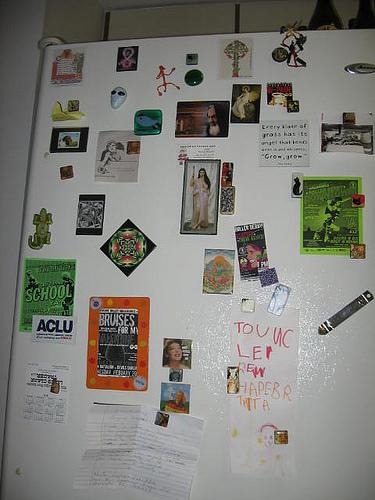What color is the refrigerator?
Keep it brief. White. What are these cards and papers attached to?
Short answer required. Refrigerator. Where is the green pieces of paper?
Short answer required. On refrigerator. 